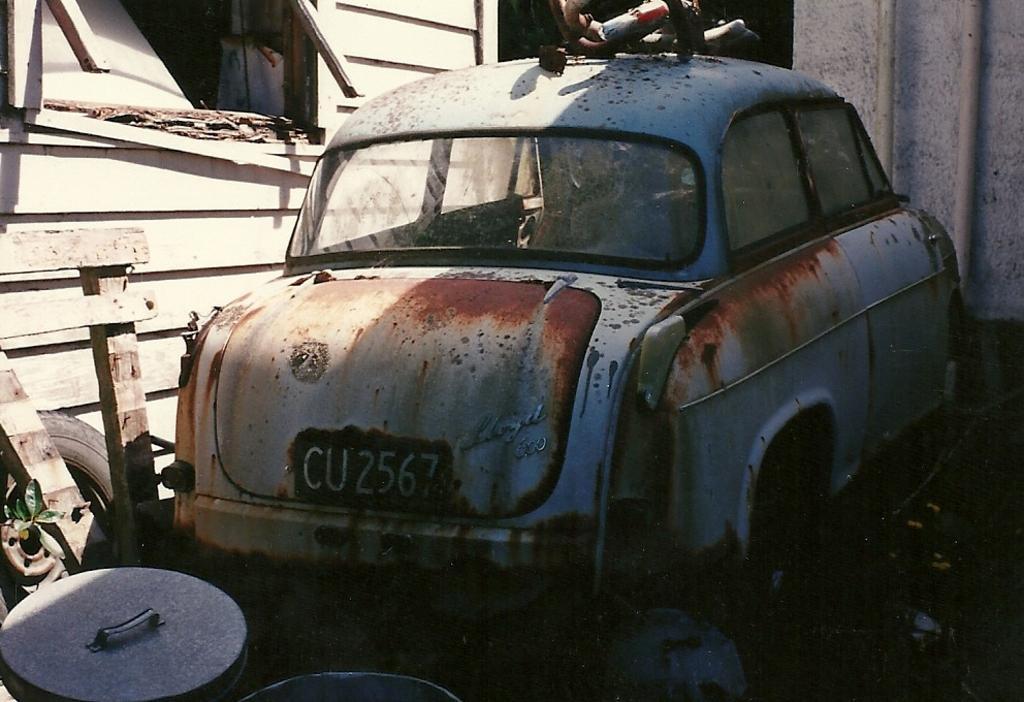Could you give a brief overview of what you see in this image? In the picture we can see a spoiled car near the shed and behind it we can see some things and some wooden planks beside it and a wooden wall. 